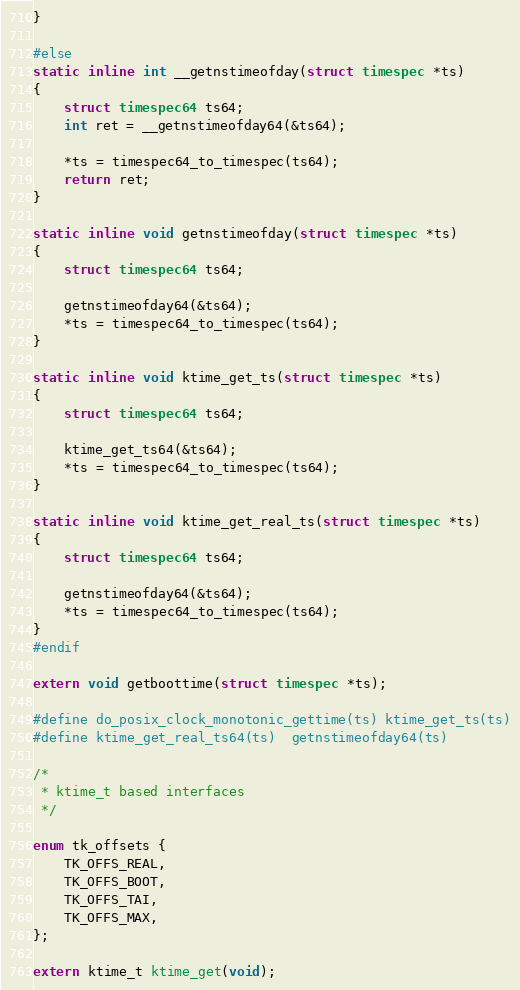Convert code to text. <code><loc_0><loc_0><loc_500><loc_500><_C_>}

#else
static inline int __getnstimeofday(struct timespec *ts)
{
	struct timespec64 ts64;
	int ret = __getnstimeofday64(&ts64);

	*ts = timespec64_to_timespec(ts64);
	return ret;
}

static inline void getnstimeofday(struct timespec *ts)
{
	struct timespec64 ts64;

	getnstimeofday64(&ts64);
	*ts = timespec64_to_timespec(ts64);
}

static inline void ktime_get_ts(struct timespec *ts)
{
	struct timespec64 ts64;

	ktime_get_ts64(&ts64);
	*ts = timespec64_to_timespec(ts64);
}

static inline void ktime_get_real_ts(struct timespec *ts)
{
	struct timespec64 ts64;

	getnstimeofday64(&ts64);
	*ts = timespec64_to_timespec(ts64);
}
#endif

extern void getboottime(struct timespec *ts);

#define do_posix_clock_monotonic_gettime(ts) ktime_get_ts(ts)
#define ktime_get_real_ts64(ts)	getnstimeofday64(ts)

/*
 * ktime_t based interfaces
 */

enum tk_offsets {
	TK_OFFS_REAL,
	TK_OFFS_BOOT,
	TK_OFFS_TAI,
	TK_OFFS_MAX,
};

extern ktime_t ktime_get(void);</code> 